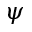<formula> <loc_0><loc_0><loc_500><loc_500>\psi</formula> 